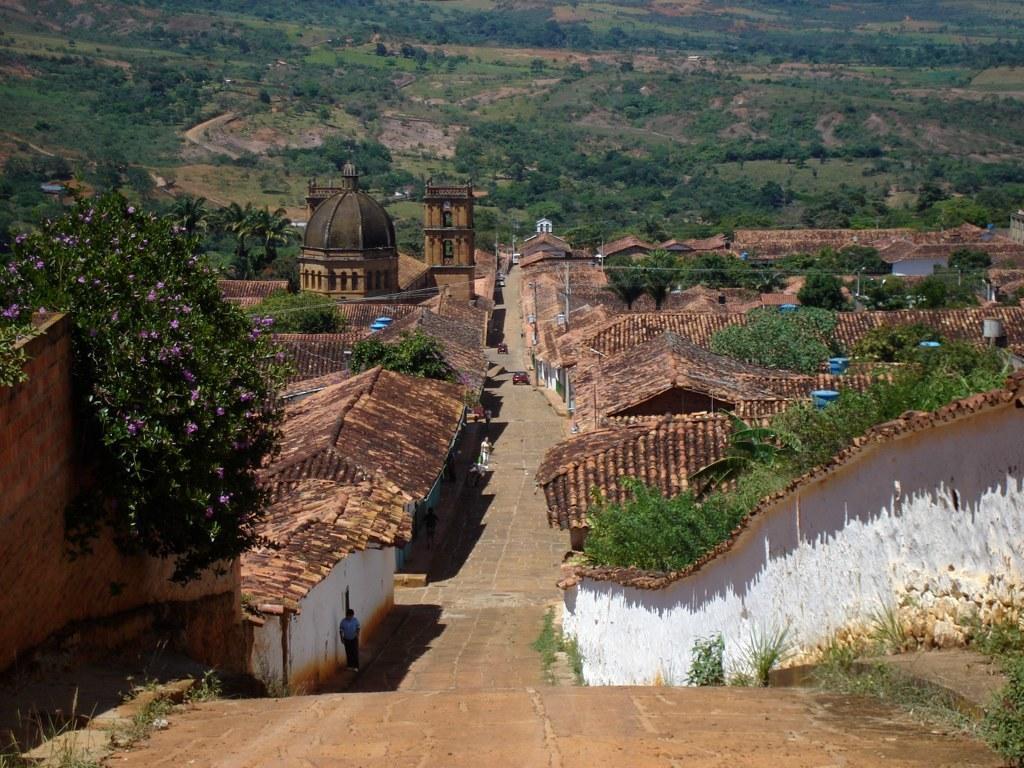Describe this image in one or two sentences. In this image I can see houses in white and brown color, few flowers in purple color and trees in green color. 